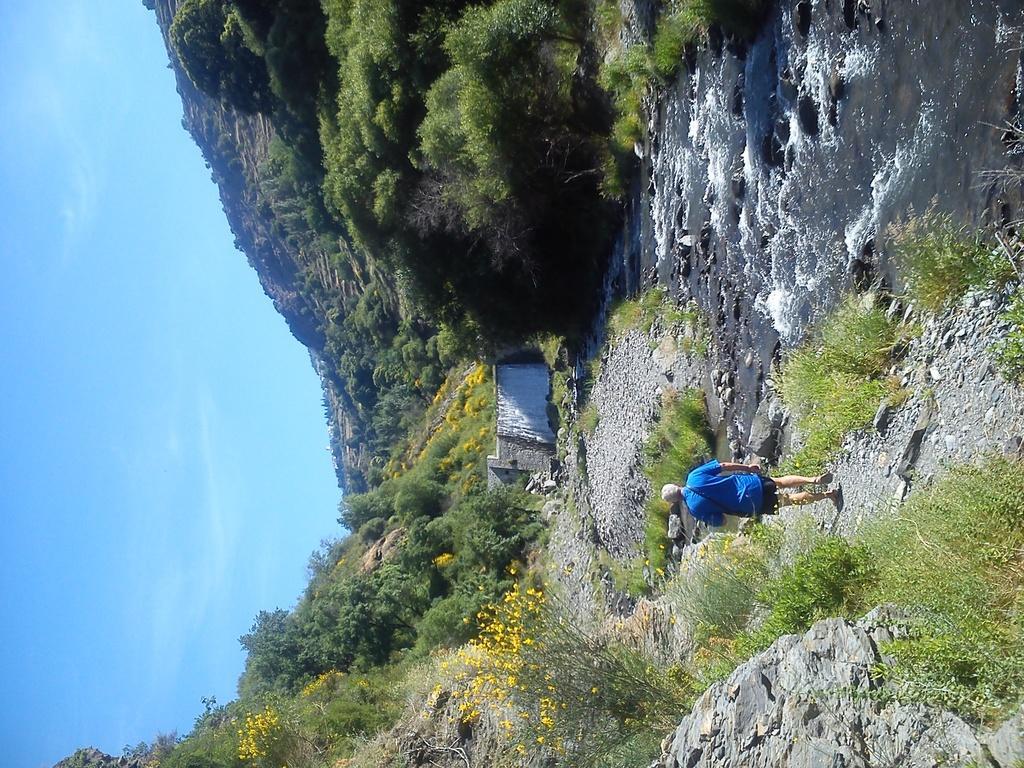How would you summarize this image in a sentence or two? In this picture we can see a person is walking on the walkway. At the top of the image, there are trees, a hill and water. At the bottom of the image, there are plants and rocks. On the left side of the image, there is the sky and an object. 